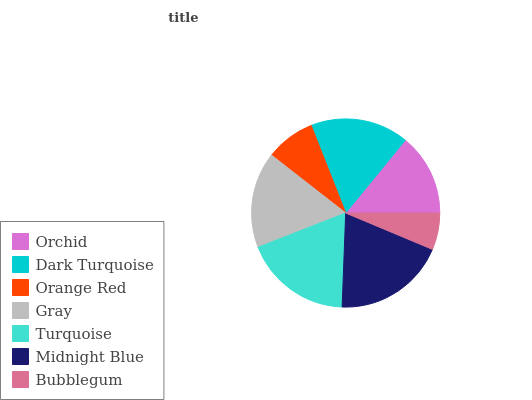Is Bubblegum the minimum?
Answer yes or no. Yes. Is Midnight Blue the maximum?
Answer yes or no. Yes. Is Dark Turquoise the minimum?
Answer yes or no. No. Is Dark Turquoise the maximum?
Answer yes or no. No. Is Dark Turquoise greater than Orchid?
Answer yes or no. Yes. Is Orchid less than Dark Turquoise?
Answer yes or no. Yes. Is Orchid greater than Dark Turquoise?
Answer yes or no. No. Is Dark Turquoise less than Orchid?
Answer yes or no. No. Is Gray the high median?
Answer yes or no. Yes. Is Gray the low median?
Answer yes or no. Yes. Is Midnight Blue the high median?
Answer yes or no. No. Is Dark Turquoise the low median?
Answer yes or no. No. 